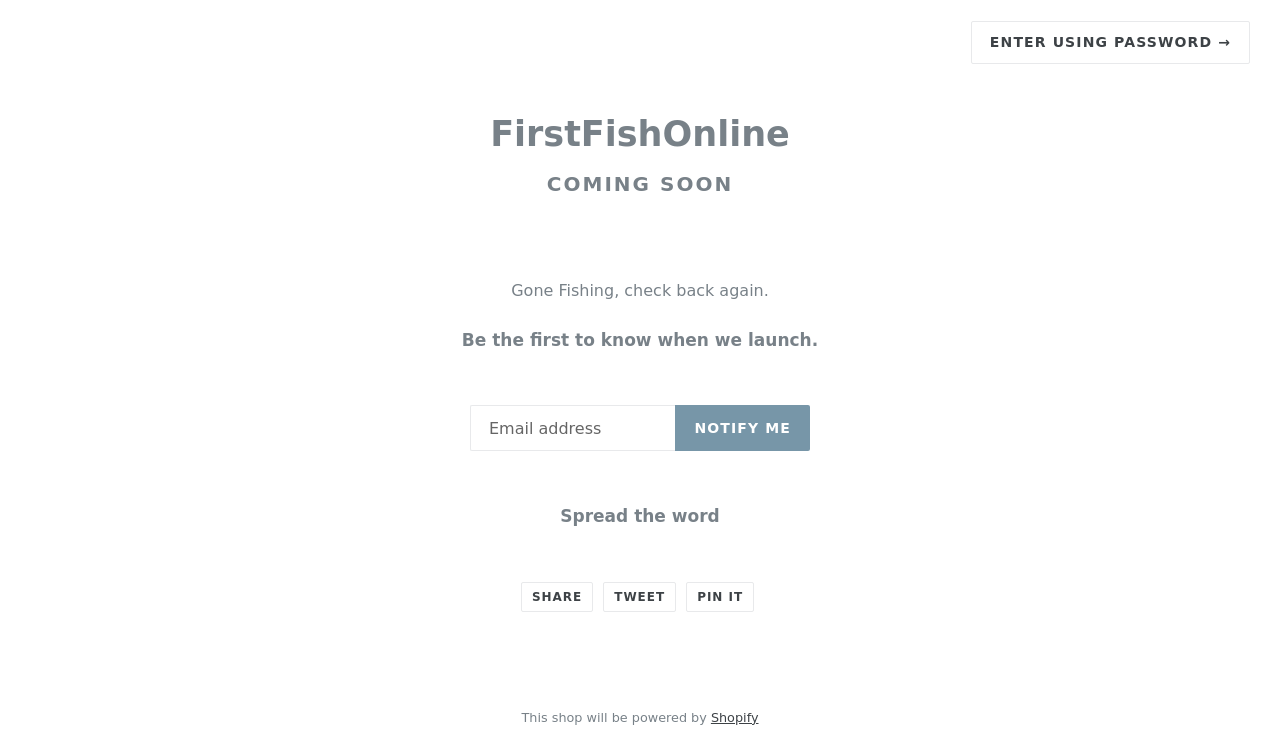Can you explain the call to action used here for collecting emails? The call to action on the website encourages visitors to enter their email address in order to receive notifications about the store's launch. This is a common strategy used to build a prospective customer base before opening, ensuring that interested users are informed and can possibly be converted into early customers once the store goes live. 